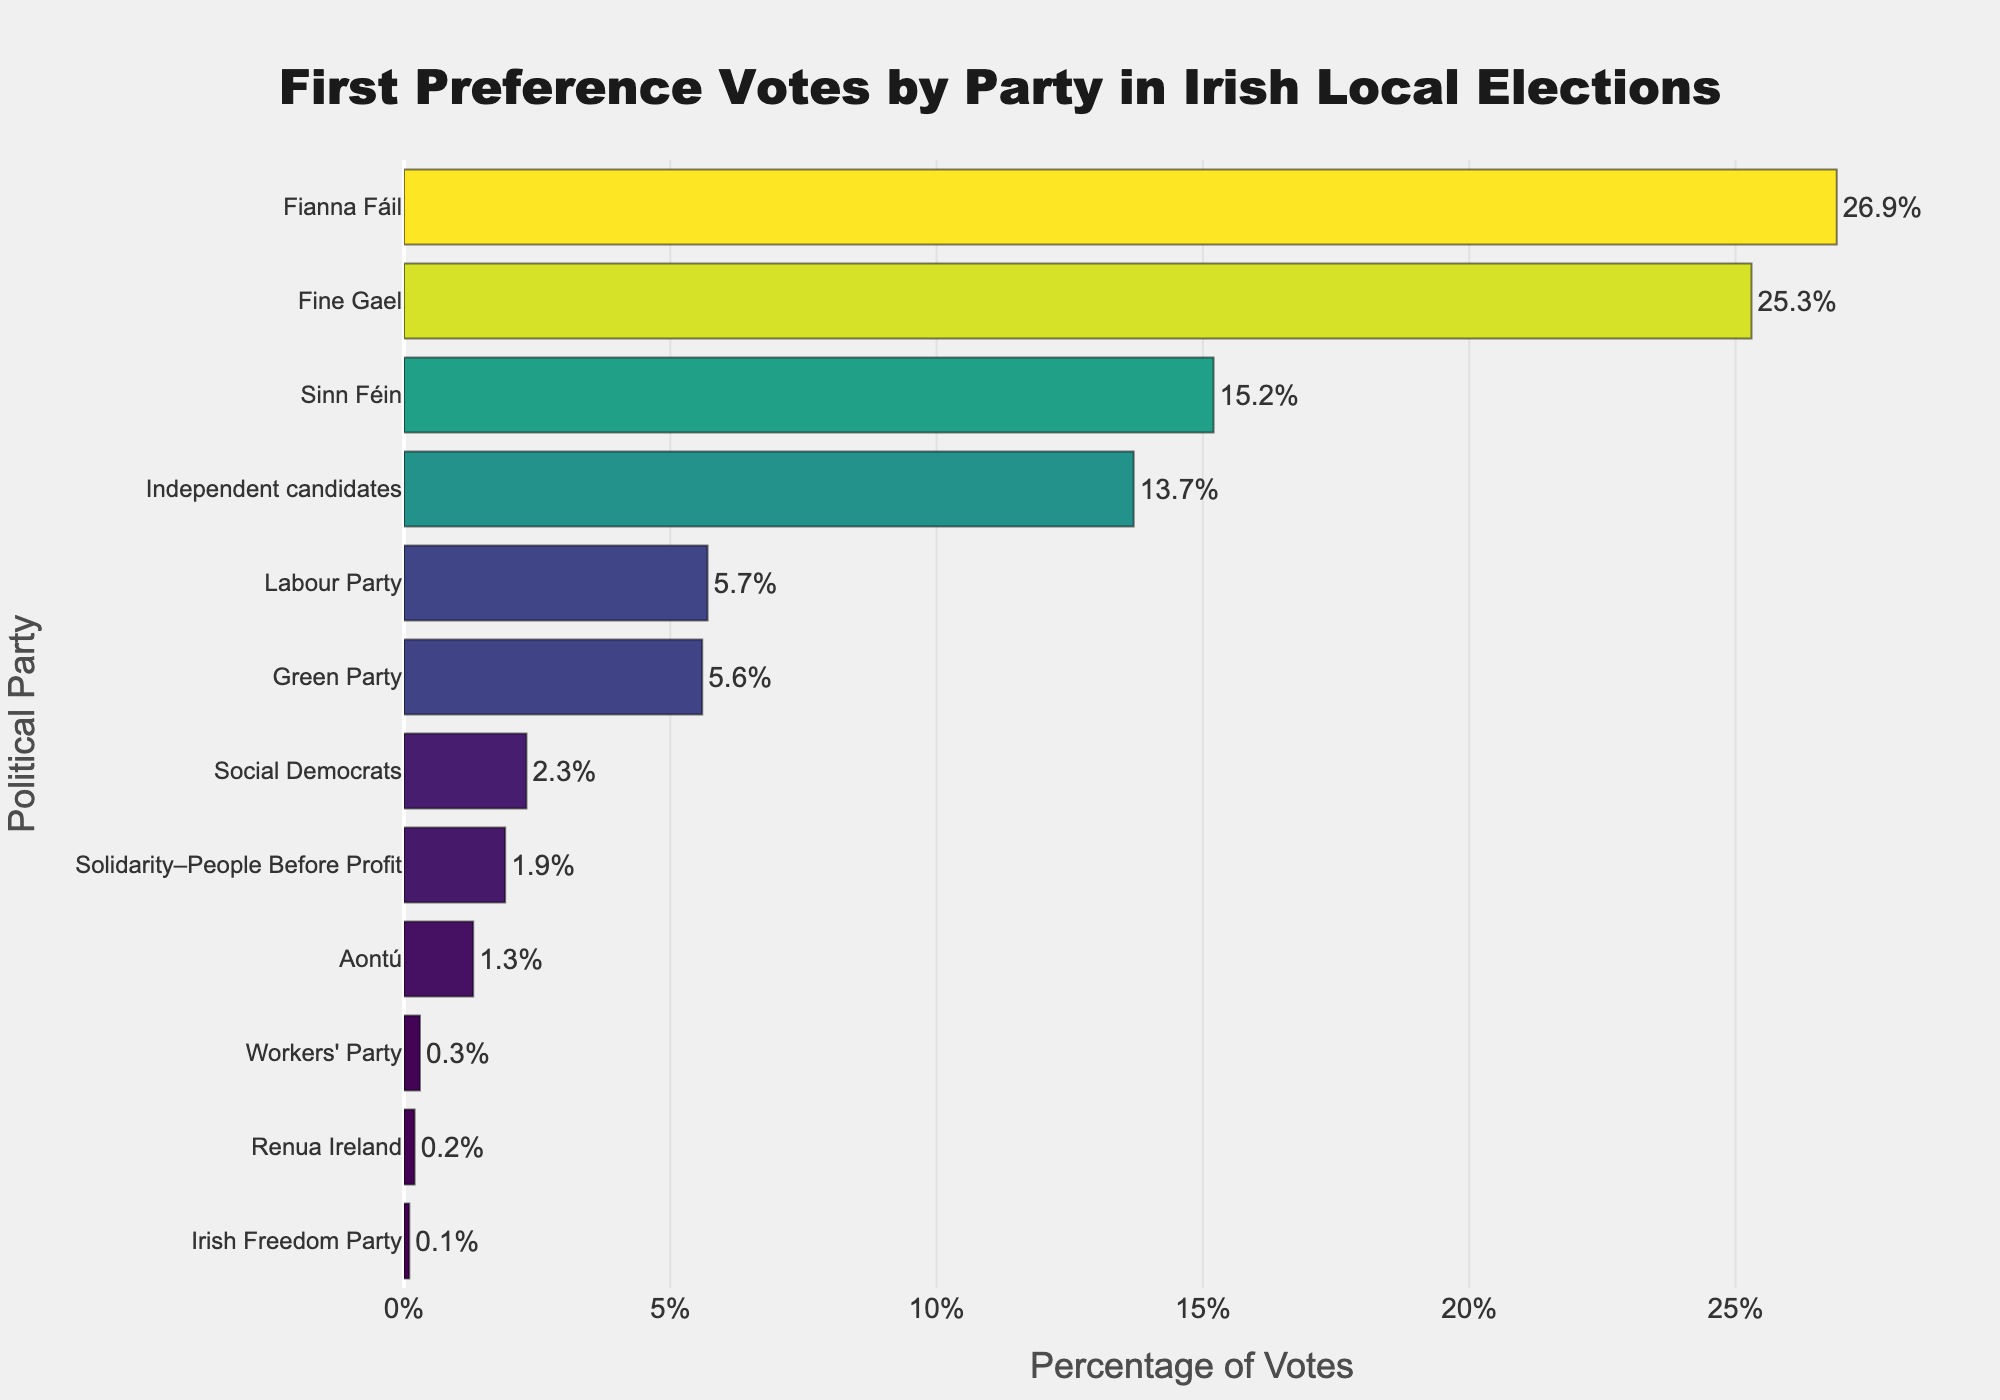What is the percentage difference between Fianna Fáil and Fine Gael? Find the percentages for both Fianna Fáil and Fine Gael from the chart. Fianna Fáil has 26.9%, and Fine Gael has 25.3%. Subtract the smaller percentage (Fine Gael) from the larger percentage (Fianna Fáil): 26.9 - 25.3.
Answer: 1.6% Which party received the lowest percentage of first preference votes? Identify the bar with the smallest value on the x-axis. The party with the smallest percentage is the Irish Freedom Party with 0.1%.
Answer: Irish Freedom Party How many parties received more than 10% of the first preference votes? Count the number of bars that extend beyond the 10% mark on the x-axis. The parties exceeding 10% are Fianna Fáil, Fine Gael, Sinn Féin, and Independent candidates.
Answer: 4 What is the total percentage of first preference votes for the Labour Party, Green Party, and Social Democrats? Locate the percentages for the Labour Party (5.7%), the Green Party (5.6%), and the Social Democrats (2.3%). Sum these values: 5.7 + 5.6 + 2.3.
Answer: 13.6% Which two parties have the closest percentage of first preference votes? Compare the percentages of all pairs and find the two closest values. The Green Party and Labour Party have the closest percentages with 5.6% and 5.7% respectively. The difference is just 0.1%.
Answer: Labour Party and Green Party How does the percentage of votes for Sinn Féin compare to the combined percentage of Solidarity–People Before Profit and Aontú? Find Sinn Féin’s percentage (15.2%) and the sum of Solidarity–People Before Profit (1.9%) and Aontú (1.3%): 1.9 + 1.3 = 3.2%. Sinn Féin’s percentage is significantly higher.
Answer: Sinn Féin is higher What is the average percentage of first preference votes received by parties that got more than 5%? Identify the parties and their percentages that got more than 5%: Fianna Fáil (26.9%), Fine Gael (25.3%), Sinn Féin (15.2%), Independent candidates (13.7%), Labour Party (5.7%), Green Party (5.6%). Sum these percentages: 26.9 + 25.3 + 15.2 + 13.7 + 5.7 + 5.6 = 92.4. Divide by the number of these parties: 92.4 / 6 = 15.4%.
Answer: 15.4% Which party holds the middle position when the percentages are sorted in descending order? Arrange the percentages in descending order and find the middle value (median). The sorted percentages are [26.9, 25.3, 15.2, 13.7, 5.7, 5.6, 2.3, 1.9, 1.3, 0.3, 0.2, 0.1]. The middle values (6th and 7th) are 5.6 and 2.3. Therefore, the middle position is occupied by Green Party.
Answer: Green Party How much higher is the percentage of votes for Fianna Fáil compared to the Green Party? Find the percentages for Fianna Fáil (26.9%) and the Green Party (5.6%). Subtract the Green Party’s percentage from Fianna Fáil’s percentage: 26.9 - 5.6.
Answer: 21.3% What is the median percentage of first preference votes among all parties? Sort the percentage values in ascending order and find the middle value. The sorted percentages are [0.1, 0.2, 0.3, 1.3, 1.9, 2.3, 5.6, 5.7, 13.7, 15.2, 25.3, 26.9]. The median is the average of the two middle values (2.3 and 5.6): (2.3 + 5.6) / 2 = 3.95%.
Answer: 3.95% 